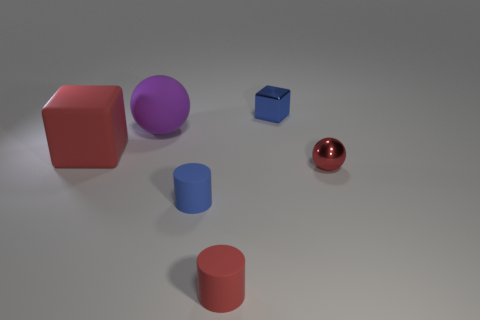Add 1 tiny red matte objects. How many objects exist? 7 Subtract all blocks. How many objects are left? 4 Add 4 small metallic balls. How many small metallic balls are left? 5 Add 6 small blue blocks. How many small blue blocks exist? 7 Subtract 0 brown cylinders. How many objects are left? 6 Subtract all small red metal things. Subtract all red rubber cylinders. How many objects are left? 4 